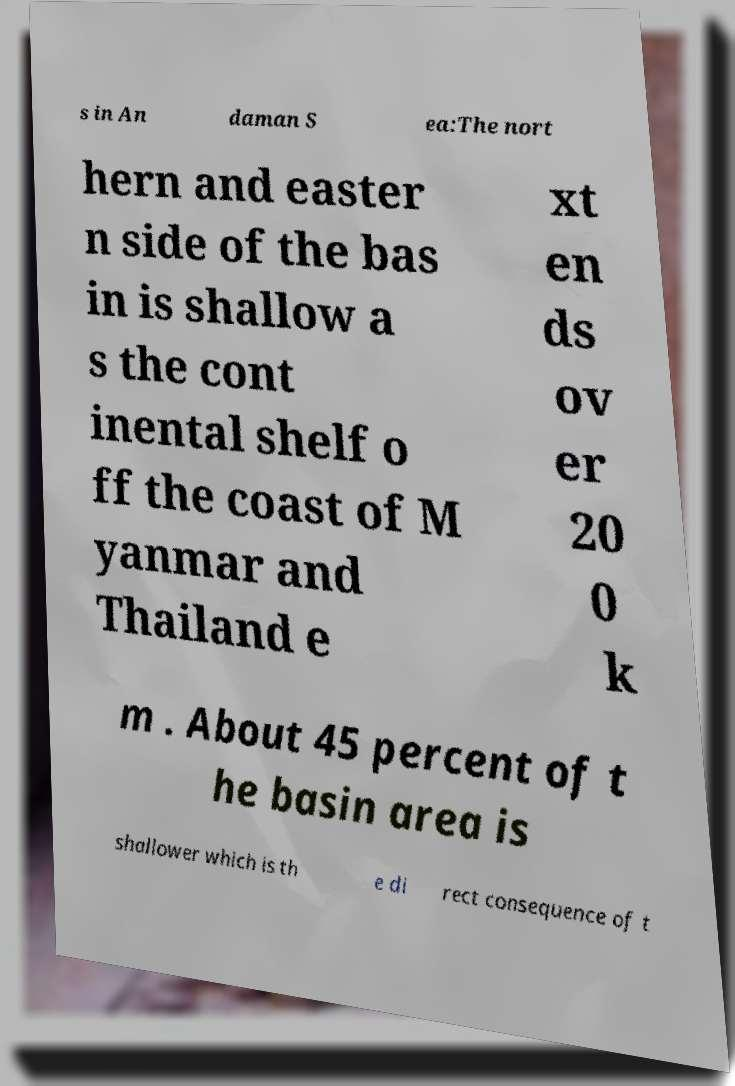What messages or text are displayed in this image? I need them in a readable, typed format. s in An daman S ea:The nort hern and easter n side of the bas in is shallow a s the cont inental shelf o ff the coast of M yanmar and Thailand e xt en ds ov er 20 0 k m . About 45 percent of t he basin area is shallower which is th e di rect consequence of t 